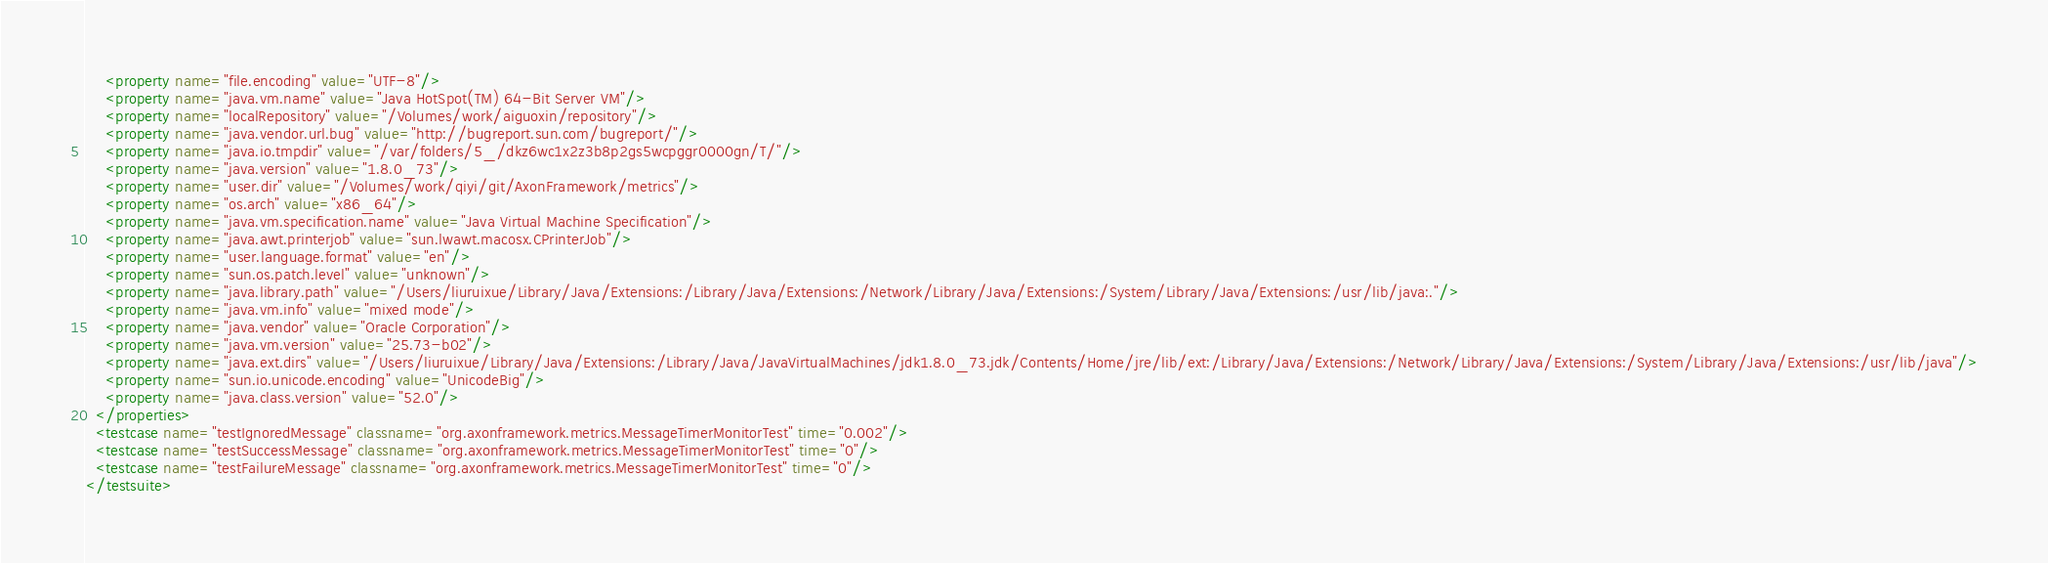Convert code to text. <code><loc_0><loc_0><loc_500><loc_500><_XML_>    <property name="file.encoding" value="UTF-8"/>
    <property name="java.vm.name" value="Java HotSpot(TM) 64-Bit Server VM"/>
    <property name="localRepository" value="/Volumes/work/aiguoxin/repository"/>
    <property name="java.vendor.url.bug" value="http://bugreport.sun.com/bugreport/"/>
    <property name="java.io.tmpdir" value="/var/folders/5_/dkz6wc1x2z3b8p2gs5wcpggr0000gn/T/"/>
    <property name="java.version" value="1.8.0_73"/>
    <property name="user.dir" value="/Volumes/work/qiyi/git/AxonFramework/metrics"/>
    <property name="os.arch" value="x86_64"/>
    <property name="java.vm.specification.name" value="Java Virtual Machine Specification"/>
    <property name="java.awt.printerjob" value="sun.lwawt.macosx.CPrinterJob"/>
    <property name="user.language.format" value="en"/>
    <property name="sun.os.patch.level" value="unknown"/>
    <property name="java.library.path" value="/Users/liuruixue/Library/Java/Extensions:/Library/Java/Extensions:/Network/Library/Java/Extensions:/System/Library/Java/Extensions:/usr/lib/java:."/>
    <property name="java.vm.info" value="mixed mode"/>
    <property name="java.vendor" value="Oracle Corporation"/>
    <property name="java.vm.version" value="25.73-b02"/>
    <property name="java.ext.dirs" value="/Users/liuruixue/Library/Java/Extensions:/Library/Java/JavaVirtualMachines/jdk1.8.0_73.jdk/Contents/Home/jre/lib/ext:/Library/Java/Extensions:/Network/Library/Java/Extensions:/System/Library/Java/Extensions:/usr/lib/java"/>
    <property name="sun.io.unicode.encoding" value="UnicodeBig"/>
    <property name="java.class.version" value="52.0"/>
  </properties>
  <testcase name="testIgnoredMessage" classname="org.axonframework.metrics.MessageTimerMonitorTest" time="0.002"/>
  <testcase name="testSuccessMessage" classname="org.axonframework.metrics.MessageTimerMonitorTest" time="0"/>
  <testcase name="testFailureMessage" classname="org.axonframework.metrics.MessageTimerMonitorTest" time="0"/>
</testsuite></code> 